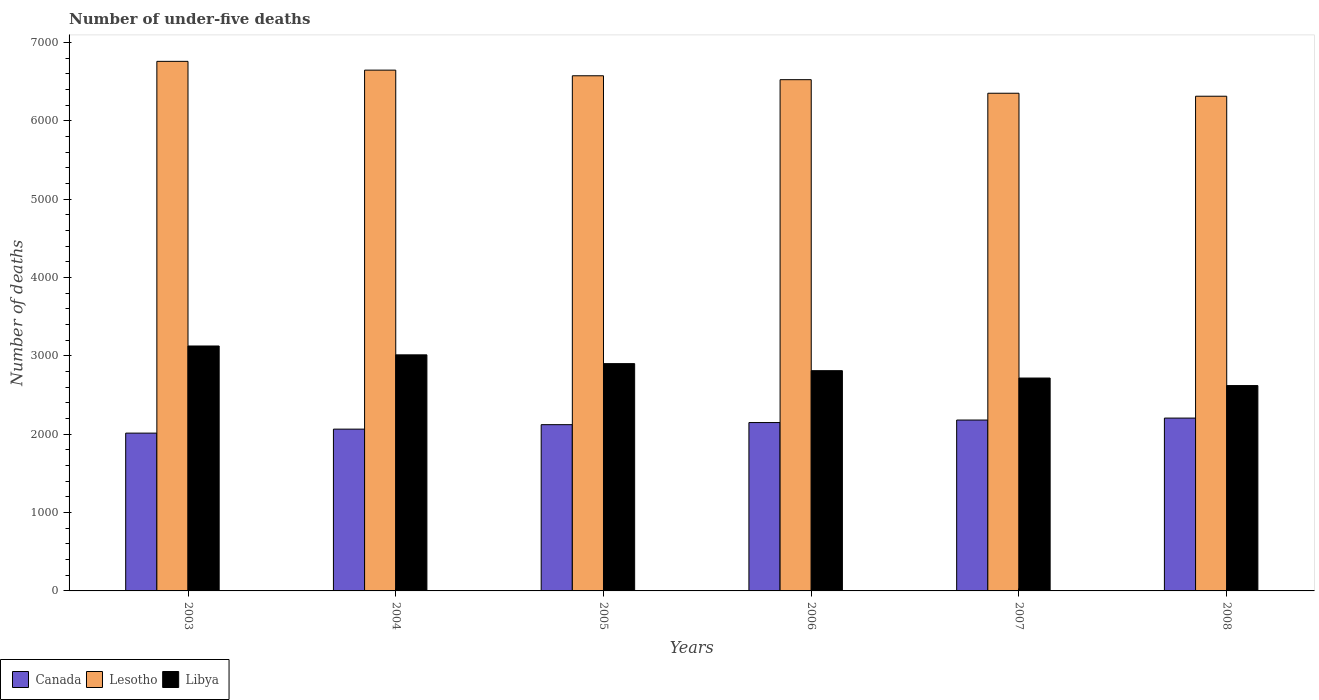How many different coloured bars are there?
Offer a terse response. 3. How many groups of bars are there?
Your answer should be compact. 6. Are the number of bars per tick equal to the number of legend labels?
Offer a very short reply. Yes. How many bars are there on the 4th tick from the left?
Keep it short and to the point. 3. What is the label of the 3rd group of bars from the left?
Offer a very short reply. 2005. In how many cases, is the number of bars for a given year not equal to the number of legend labels?
Provide a short and direct response. 0. What is the number of under-five deaths in Libya in 2006?
Make the answer very short. 2811. Across all years, what is the maximum number of under-five deaths in Lesotho?
Your response must be concise. 6759. Across all years, what is the minimum number of under-five deaths in Canada?
Ensure brevity in your answer.  2014. In which year was the number of under-five deaths in Libya maximum?
Your answer should be very brief. 2003. In which year was the number of under-five deaths in Canada minimum?
Offer a very short reply. 2003. What is the total number of under-five deaths in Canada in the graph?
Ensure brevity in your answer.  1.27e+04. What is the difference between the number of under-five deaths in Canada in 2004 and that in 2007?
Provide a succinct answer. -116. What is the difference between the number of under-five deaths in Canada in 2003 and the number of under-five deaths in Lesotho in 2004?
Make the answer very short. -4633. What is the average number of under-five deaths in Libya per year?
Your answer should be very brief. 2864.83. In the year 2006, what is the difference between the number of under-five deaths in Canada and number of under-five deaths in Libya?
Your answer should be compact. -662. In how many years, is the number of under-five deaths in Libya greater than 2200?
Ensure brevity in your answer.  6. What is the ratio of the number of under-five deaths in Canada in 2007 to that in 2008?
Make the answer very short. 0.99. Is the number of under-five deaths in Canada in 2007 less than that in 2008?
Keep it short and to the point. Yes. What is the difference between the highest and the second highest number of under-five deaths in Lesotho?
Ensure brevity in your answer.  112. What is the difference between the highest and the lowest number of under-five deaths in Lesotho?
Offer a very short reply. 445. In how many years, is the number of under-five deaths in Lesotho greater than the average number of under-five deaths in Lesotho taken over all years?
Your answer should be compact. 3. What does the 1st bar from the left in 2006 represents?
Provide a succinct answer. Canada. What does the 3rd bar from the right in 2005 represents?
Your answer should be compact. Canada. Is it the case that in every year, the sum of the number of under-five deaths in Canada and number of under-five deaths in Libya is greater than the number of under-five deaths in Lesotho?
Ensure brevity in your answer.  No. How many years are there in the graph?
Provide a short and direct response. 6. What is the difference between two consecutive major ticks on the Y-axis?
Offer a very short reply. 1000. Are the values on the major ticks of Y-axis written in scientific E-notation?
Give a very brief answer. No. Does the graph contain any zero values?
Your answer should be compact. No. Does the graph contain grids?
Offer a terse response. No. What is the title of the graph?
Your answer should be very brief. Number of under-five deaths. Does "Djibouti" appear as one of the legend labels in the graph?
Give a very brief answer. No. What is the label or title of the Y-axis?
Give a very brief answer. Number of deaths. What is the Number of deaths in Canada in 2003?
Offer a terse response. 2014. What is the Number of deaths of Lesotho in 2003?
Your answer should be compact. 6759. What is the Number of deaths in Libya in 2003?
Your answer should be very brief. 3126. What is the Number of deaths in Canada in 2004?
Make the answer very short. 2065. What is the Number of deaths of Lesotho in 2004?
Give a very brief answer. 6647. What is the Number of deaths in Libya in 2004?
Offer a very short reply. 3013. What is the Number of deaths in Canada in 2005?
Give a very brief answer. 2122. What is the Number of deaths in Lesotho in 2005?
Ensure brevity in your answer.  6575. What is the Number of deaths of Libya in 2005?
Your response must be concise. 2901. What is the Number of deaths in Canada in 2006?
Your answer should be very brief. 2149. What is the Number of deaths of Lesotho in 2006?
Your answer should be very brief. 6525. What is the Number of deaths of Libya in 2006?
Your response must be concise. 2811. What is the Number of deaths of Canada in 2007?
Provide a short and direct response. 2181. What is the Number of deaths in Lesotho in 2007?
Your response must be concise. 6352. What is the Number of deaths in Libya in 2007?
Give a very brief answer. 2717. What is the Number of deaths in Canada in 2008?
Give a very brief answer. 2206. What is the Number of deaths of Lesotho in 2008?
Offer a very short reply. 6314. What is the Number of deaths of Libya in 2008?
Ensure brevity in your answer.  2621. Across all years, what is the maximum Number of deaths in Canada?
Provide a succinct answer. 2206. Across all years, what is the maximum Number of deaths in Lesotho?
Ensure brevity in your answer.  6759. Across all years, what is the maximum Number of deaths in Libya?
Ensure brevity in your answer.  3126. Across all years, what is the minimum Number of deaths in Canada?
Offer a very short reply. 2014. Across all years, what is the minimum Number of deaths in Lesotho?
Provide a succinct answer. 6314. Across all years, what is the minimum Number of deaths of Libya?
Your response must be concise. 2621. What is the total Number of deaths of Canada in the graph?
Your answer should be compact. 1.27e+04. What is the total Number of deaths in Lesotho in the graph?
Provide a short and direct response. 3.92e+04. What is the total Number of deaths in Libya in the graph?
Offer a terse response. 1.72e+04. What is the difference between the Number of deaths in Canada in 2003 and that in 2004?
Your answer should be very brief. -51. What is the difference between the Number of deaths in Lesotho in 2003 and that in 2004?
Provide a short and direct response. 112. What is the difference between the Number of deaths of Libya in 2003 and that in 2004?
Offer a terse response. 113. What is the difference between the Number of deaths of Canada in 2003 and that in 2005?
Provide a succinct answer. -108. What is the difference between the Number of deaths in Lesotho in 2003 and that in 2005?
Provide a short and direct response. 184. What is the difference between the Number of deaths in Libya in 2003 and that in 2005?
Your answer should be compact. 225. What is the difference between the Number of deaths of Canada in 2003 and that in 2006?
Your answer should be compact. -135. What is the difference between the Number of deaths in Lesotho in 2003 and that in 2006?
Provide a succinct answer. 234. What is the difference between the Number of deaths in Libya in 2003 and that in 2006?
Your answer should be compact. 315. What is the difference between the Number of deaths of Canada in 2003 and that in 2007?
Your answer should be compact. -167. What is the difference between the Number of deaths of Lesotho in 2003 and that in 2007?
Offer a terse response. 407. What is the difference between the Number of deaths of Libya in 2003 and that in 2007?
Your answer should be compact. 409. What is the difference between the Number of deaths in Canada in 2003 and that in 2008?
Ensure brevity in your answer.  -192. What is the difference between the Number of deaths of Lesotho in 2003 and that in 2008?
Provide a short and direct response. 445. What is the difference between the Number of deaths in Libya in 2003 and that in 2008?
Your response must be concise. 505. What is the difference between the Number of deaths of Canada in 2004 and that in 2005?
Offer a terse response. -57. What is the difference between the Number of deaths in Lesotho in 2004 and that in 2005?
Keep it short and to the point. 72. What is the difference between the Number of deaths in Libya in 2004 and that in 2005?
Give a very brief answer. 112. What is the difference between the Number of deaths in Canada in 2004 and that in 2006?
Your answer should be very brief. -84. What is the difference between the Number of deaths of Lesotho in 2004 and that in 2006?
Ensure brevity in your answer.  122. What is the difference between the Number of deaths in Libya in 2004 and that in 2006?
Provide a short and direct response. 202. What is the difference between the Number of deaths in Canada in 2004 and that in 2007?
Offer a terse response. -116. What is the difference between the Number of deaths in Lesotho in 2004 and that in 2007?
Provide a short and direct response. 295. What is the difference between the Number of deaths of Libya in 2004 and that in 2007?
Give a very brief answer. 296. What is the difference between the Number of deaths in Canada in 2004 and that in 2008?
Provide a short and direct response. -141. What is the difference between the Number of deaths in Lesotho in 2004 and that in 2008?
Ensure brevity in your answer.  333. What is the difference between the Number of deaths of Libya in 2004 and that in 2008?
Offer a terse response. 392. What is the difference between the Number of deaths in Canada in 2005 and that in 2006?
Give a very brief answer. -27. What is the difference between the Number of deaths in Libya in 2005 and that in 2006?
Your answer should be very brief. 90. What is the difference between the Number of deaths in Canada in 2005 and that in 2007?
Keep it short and to the point. -59. What is the difference between the Number of deaths in Lesotho in 2005 and that in 2007?
Make the answer very short. 223. What is the difference between the Number of deaths of Libya in 2005 and that in 2007?
Provide a succinct answer. 184. What is the difference between the Number of deaths in Canada in 2005 and that in 2008?
Your answer should be compact. -84. What is the difference between the Number of deaths in Lesotho in 2005 and that in 2008?
Provide a succinct answer. 261. What is the difference between the Number of deaths of Libya in 2005 and that in 2008?
Offer a very short reply. 280. What is the difference between the Number of deaths of Canada in 2006 and that in 2007?
Keep it short and to the point. -32. What is the difference between the Number of deaths of Lesotho in 2006 and that in 2007?
Offer a very short reply. 173. What is the difference between the Number of deaths in Libya in 2006 and that in 2007?
Offer a terse response. 94. What is the difference between the Number of deaths in Canada in 2006 and that in 2008?
Your response must be concise. -57. What is the difference between the Number of deaths of Lesotho in 2006 and that in 2008?
Your answer should be very brief. 211. What is the difference between the Number of deaths of Libya in 2006 and that in 2008?
Provide a succinct answer. 190. What is the difference between the Number of deaths in Canada in 2007 and that in 2008?
Provide a short and direct response. -25. What is the difference between the Number of deaths in Lesotho in 2007 and that in 2008?
Offer a very short reply. 38. What is the difference between the Number of deaths in Libya in 2007 and that in 2008?
Your answer should be compact. 96. What is the difference between the Number of deaths in Canada in 2003 and the Number of deaths in Lesotho in 2004?
Keep it short and to the point. -4633. What is the difference between the Number of deaths of Canada in 2003 and the Number of deaths of Libya in 2004?
Give a very brief answer. -999. What is the difference between the Number of deaths in Lesotho in 2003 and the Number of deaths in Libya in 2004?
Offer a terse response. 3746. What is the difference between the Number of deaths in Canada in 2003 and the Number of deaths in Lesotho in 2005?
Keep it short and to the point. -4561. What is the difference between the Number of deaths in Canada in 2003 and the Number of deaths in Libya in 2005?
Provide a succinct answer. -887. What is the difference between the Number of deaths of Lesotho in 2003 and the Number of deaths of Libya in 2005?
Make the answer very short. 3858. What is the difference between the Number of deaths in Canada in 2003 and the Number of deaths in Lesotho in 2006?
Your answer should be very brief. -4511. What is the difference between the Number of deaths of Canada in 2003 and the Number of deaths of Libya in 2006?
Make the answer very short. -797. What is the difference between the Number of deaths of Lesotho in 2003 and the Number of deaths of Libya in 2006?
Offer a terse response. 3948. What is the difference between the Number of deaths in Canada in 2003 and the Number of deaths in Lesotho in 2007?
Your answer should be compact. -4338. What is the difference between the Number of deaths of Canada in 2003 and the Number of deaths of Libya in 2007?
Provide a short and direct response. -703. What is the difference between the Number of deaths of Lesotho in 2003 and the Number of deaths of Libya in 2007?
Provide a short and direct response. 4042. What is the difference between the Number of deaths in Canada in 2003 and the Number of deaths in Lesotho in 2008?
Provide a succinct answer. -4300. What is the difference between the Number of deaths in Canada in 2003 and the Number of deaths in Libya in 2008?
Your answer should be very brief. -607. What is the difference between the Number of deaths in Lesotho in 2003 and the Number of deaths in Libya in 2008?
Offer a terse response. 4138. What is the difference between the Number of deaths in Canada in 2004 and the Number of deaths in Lesotho in 2005?
Offer a terse response. -4510. What is the difference between the Number of deaths of Canada in 2004 and the Number of deaths of Libya in 2005?
Offer a terse response. -836. What is the difference between the Number of deaths of Lesotho in 2004 and the Number of deaths of Libya in 2005?
Keep it short and to the point. 3746. What is the difference between the Number of deaths of Canada in 2004 and the Number of deaths of Lesotho in 2006?
Keep it short and to the point. -4460. What is the difference between the Number of deaths in Canada in 2004 and the Number of deaths in Libya in 2006?
Provide a short and direct response. -746. What is the difference between the Number of deaths in Lesotho in 2004 and the Number of deaths in Libya in 2006?
Ensure brevity in your answer.  3836. What is the difference between the Number of deaths of Canada in 2004 and the Number of deaths of Lesotho in 2007?
Your answer should be very brief. -4287. What is the difference between the Number of deaths in Canada in 2004 and the Number of deaths in Libya in 2007?
Provide a succinct answer. -652. What is the difference between the Number of deaths in Lesotho in 2004 and the Number of deaths in Libya in 2007?
Keep it short and to the point. 3930. What is the difference between the Number of deaths in Canada in 2004 and the Number of deaths in Lesotho in 2008?
Your response must be concise. -4249. What is the difference between the Number of deaths of Canada in 2004 and the Number of deaths of Libya in 2008?
Make the answer very short. -556. What is the difference between the Number of deaths of Lesotho in 2004 and the Number of deaths of Libya in 2008?
Give a very brief answer. 4026. What is the difference between the Number of deaths of Canada in 2005 and the Number of deaths of Lesotho in 2006?
Provide a short and direct response. -4403. What is the difference between the Number of deaths of Canada in 2005 and the Number of deaths of Libya in 2006?
Provide a short and direct response. -689. What is the difference between the Number of deaths of Lesotho in 2005 and the Number of deaths of Libya in 2006?
Offer a very short reply. 3764. What is the difference between the Number of deaths of Canada in 2005 and the Number of deaths of Lesotho in 2007?
Your response must be concise. -4230. What is the difference between the Number of deaths of Canada in 2005 and the Number of deaths of Libya in 2007?
Keep it short and to the point. -595. What is the difference between the Number of deaths of Lesotho in 2005 and the Number of deaths of Libya in 2007?
Ensure brevity in your answer.  3858. What is the difference between the Number of deaths in Canada in 2005 and the Number of deaths in Lesotho in 2008?
Your answer should be very brief. -4192. What is the difference between the Number of deaths of Canada in 2005 and the Number of deaths of Libya in 2008?
Ensure brevity in your answer.  -499. What is the difference between the Number of deaths in Lesotho in 2005 and the Number of deaths in Libya in 2008?
Make the answer very short. 3954. What is the difference between the Number of deaths of Canada in 2006 and the Number of deaths of Lesotho in 2007?
Offer a very short reply. -4203. What is the difference between the Number of deaths in Canada in 2006 and the Number of deaths in Libya in 2007?
Offer a terse response. -568. What is the difference between the Number of deaths of Lesotho in 2006 and the Number of deaths of Libya in 2007?
Your answer should be compact. 3808. What is the difference between the Number of deaths in Canada in 2006 and the Number of deaths in Lesotho in 2008?
Provide a short and direct response. -4165. What is the difference between the Number of deaths of Canada in 2006 and the Number of deaths of Libya in 2008?
Keep it short and to the point. -472. What is the difference between the Number of deaths in Lesotho in 2006 and the Number of deaths in Libya in 2008?
Make the answer very short. 3904. What is the difference between the Number of deaths in Canada in 2007 and the Number of deaths in Lesotho in 2008?
Your answer should be very brief. -4133. What is the difference between the Number of deaths of Canada in 2007 and the Number of deaths of Libya in 2008?
Give a very brief answer. -440. What is the difference between the Number of deaths in Lesotho in 2007 and the Number of deaths in Libya in 2008?
Offer a very short reply. 3731. What is the average Number of deaths in Canada per year?
Your answer should be compact. 2122.83. What is the average Number of deaths in Lesotho per year?
Make the answer very short. 6528.67. What is the average Number of deaths in Libya per year?
Your response must be concise. 2864.83. In the year 2003, what is the difference between the Number of deaths of Canada and Number of deaths of Lesotho?
Give a very brief answer. -4745. In the year 2003, what is the difference between the Number of deaths in Canada and Number of deaths in Libya?
Ensure brevity in your answer.  -1112. In the year 2003, what is the difference between the Number of deaths of Lesotho and Number of deaths of Libya?
Offer a terse response. 3633. In the year 2004, what is the difference between the Number of deaths in Canada and Number of deaths in Lesotho?
Your response must be concise. -4582. In the year 2004, what is the difference between the Number of deaths of Canada and Number of deaths of Libya?
Keep it short and to the point. -948. In the year 2004, what is the difference between the Number of deaths of Lesotho and Number of deaths of Libya?
Your answer should be compact. 3634. In the year 2005, what is the difference between the Number of deaths in Canada and Number of deaths in Lesotho?
Your response must be concise. -4453. In the year 2005, what is the difference between the Number of deaths in Canada and Number of deaths in Libya?
Ensure brevity in your answer.  -779. In the year 2005, what is the difference between the Number of deaths in Lesotho and Number of deaths in Libya?
Your answer should be compact. 3674. In the year 2006, what is the difference between the Number of deaths of Canada and Number of deaths of Lesotho?
Your answer should be compact. -4376. In the year 2006, what is the difference between the Number of deaths of Canada and Number of deaths of Libya?
Give a very brief answer. -662. In the year 2006, what is the difference between the Number of deaths in Lesotho and Number of deaths in Libya?
Your answer should be very brief. 3714. In the year 2007, what is the difference between the Number of deaths in Canada and Number of deaths in Lesotho?
Provide a short and direct response. -4171. In the year 2007, what is the difference between the Number of deaths in Canada and Number of deaths in Libya?
Provide a succinct answer. -536. In the year 2007, what is the difference between the Number of deaths in Lesotho and Number of deaths in Libya?
Offer a very short reply. 3635. In the year 2008, what is the difference between the Number of deaths in Canada and Number of deaths in Lesotho?
Ensure brevity in your answer.  -4108. In the year 2008, what is the difference between the Number of deaths of Canada and Number of deaths of Libya?
Your answer should be compact. -415. In the year 2008, what is the difference between the Number of deaths of Lesotho and Number of deaths of Libya?
Keep it short and to the point. 3693. What is the ratio of the Number of deaths of Canada in 2003 to that in 2004?
Offer a very short reply. 0.98. What is the ratio of the Number of deaths of Lesotho in 2003 to that in 2004?
Your answer should be very brief. 1.02. What is the ratio of the Number of deaths of Libya in 2003 to that in 2004?
Give a very brief answer. 1.04. What is the ratio of the Number of deaths of Canada in 2003 to that in 2005?
Your answer should be very brief. 0.95. What is the ratio of the Number of deaths of Lesotho in 2003 to that in 2005?
Keep it short and to the point. 1.03. What is the ratio of the Number of deaths of Libya in 2003 to that in 2005?
Keep it short and to the point. 1.08. What is the ratio of the Number of deaths in Canada in 2003 to that in 2006?
Ensure brevity in your answer.  0.94. What is the ratio of the Number of deaths in Lesotho in 2003 to that in 2006?
Provide a short and direct response. 1.04. What is the ratio of the Number of deaths in Libya in 2003 to that in 2006?
Offer a terse response. 1.11. What is the ratio of the Number of deaths of Canada in 2003 to that in 2007?
Your response must be concise. 0.92. What is the ratio of the Number of deaths of Lesotho in 2003 to that in 2007?
Offer a terse response. 1.06. What is the ratio of the Number of deaths of Libya in 2003 to that in 2007?
Give a very brief answer. 1.15. What is the ratio of the Number of deaths in Canada in 2003 to that in 2008?
Offer a terse response. 0.91. What is the ratio of the Number of deaths in Lesotho in 2003 to that in 2008?
Keep it short and to the point. 1.07. What is the ratio of the Number of deaths in Libya in 2003 to that in 2008?
Ensure brevity in your answer.  1.19. What is the ratio of the Number of deaths of Canada in 2004 to that in 2005?
Your answer should be compact. 0.97. What is the ratio of the Number of deaths in Lesotho in 2004 to that in 2005?
Your answer should be compact. 1.01. What is the ratio of the Number of deaths in Libya in 2004 to that in 2005?
Keep it short and to the point. 1.04. What is the ratio of the Number of deaths of Canada in 2004 to that in 2006?
Your response must be concise. 0.96. What is the ratio of the Number of deaths in Lesotho in 2004 to that in 2006?
Provide a succinct answer. 1.02. What is the ratio of the Number of deaths of Libya in 2004 to that in 2006?
Your answer should be very brief. 1.07. What is the ratio of the Number of deaths of Canada in 2004 to that in 2007?
Your answer should be compact. 0.95. What is the ratio of the Number of deaths of Lesotho in 2004 to that in 2007?
Offer a terse response. 1.05. What is the ratio of the Number of deaths in Libya in 2004 to that in 2007?
Give a very brief answer. 1.11. What is the ratio of the Number of deaths of Canada in 2004 to that in 2008?
Provide a succinct answer. 0.94. What is the ratio of the Number of deaths of Lesotho in 2004 to that in 2008?
Keep it short and to the point. 1.05. What is the ratio of the Number of deaths of Libya in 2004 to that in 2008?
Provide a succinct answer. 1.15. What is the ratio of the Number of deaths of Canada in 2005 to that in 2006?
Offer a very short reply. 0.99. What is the ratio of the Number of deaths in Lesotho in 2005 to that in 2006?
Give a very brief answer. 1.01. What is the ratio of the Number of deaths in Libya in 2005 to that in 2006?
Provide a short and direct response. 1.03. What is the ratio of the Number of deaths of Canada in 2005 to that in 2007?
Provide a succinct answer. 0.97. What is the ratio of the Number of deaths in Lesotho in 2005 to that in 2007?
Provide a succinct answer. 1.04. What is the ratio of the Number of deaths of Libya in 2005 to that in 2007?
Give a very brief answer. 1.07. What is the ratio of the Number of deaths in Canada in 2005 to that in 2008?
Offer a very short reply. 0.96. What is the ratio of the Number of deaths in Lesotho in 2005 to that in 2008?
Give a very brief answer. 1.04. What is the ratio of the Number of deaths in Libya in 2005 to that in 2008?
Offer a terse response. 1.11. What is the ratio of the Number of deaths of Canada in 2006 to that in 2007?
Ensure brevity in your answer.  0.99. What is the ratio of the Number of deaths of Lesotho in 2006 to that in 2007?
Your response must be concise. 1.03. What is the ratio of the Number of deaths in Libya in 2006 to that in 2007?
Your response must be concise. 1.03. What is the ratio of the Number of deaths in Canada in 2006 to that in 2008?
Your response must be concise. 0.97. What is the ratio of the Number of deaths in Lesotho in 2006 to that in 2008?
Give a very brief answer. 1.03. What is the ratio of the Number of deaths in Libya in 2006 to that in 2008?
Your answer should be compact. 1.07. What is the ratio of the Number of deaths of Canada in 2007 to that in 2008?
Ensure brevity in your answer.  0.99. What is the ratio of the Number of deaths of Libya in 2007 to that in 2008?
Provide a short and direct response. 1.04. What is the difference between the highest and the second highest Number of deaths of Canada?
Offer a terse response. 25. What is the difference between the highest and the second highest Number of deaths of Lesotho?
Provide a short and direct response. 112. What is the difference between the highest and the second highest Number of deaths of Libya?
Provide a short and direct response. 113. What is the difference between the highest and the lowest Number of deaths in Canada?
Your response must be concise. 192. What is the difference between the highest and the lowest Number of deaths in Lesotho?
Your answer should be compact. 445. What is the difference between the highest and the lowest Number of deaths of Libya?
Keep it short and to the point. 505. 